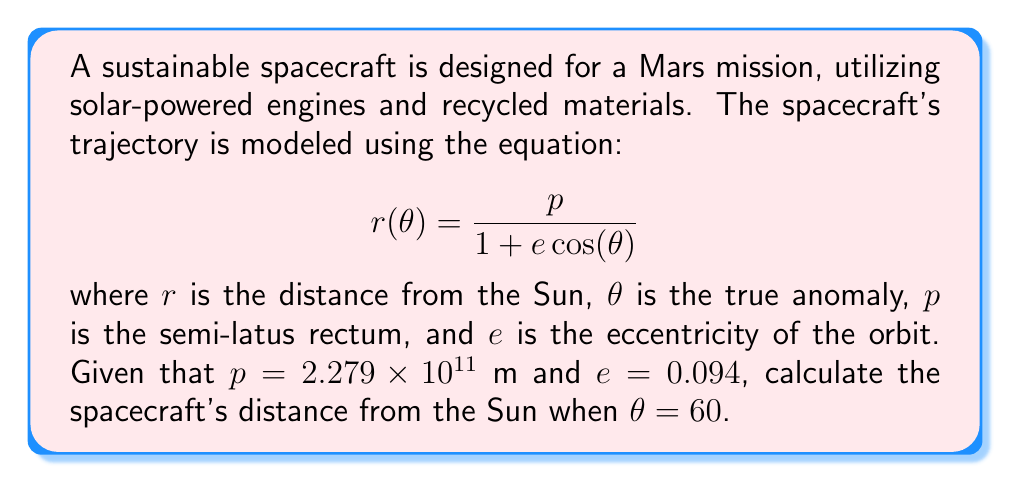Can you solve this math problem? To solve this problem, we'll follow these steps:

1. Identify the given values:
   $p = 2.279 \times 10^{11}$ m
   $e = 0.094$
   $\theta = 60°$

2. Convert 60° to radians:
   $60° = \frac{60 \pi}{180} = \frac{\pi}{3}$ radians

3. Substitute the values into the equation:
   $$r(\theta) = \frac{p}{1 + e \cos(\theta)}$$
   $$r(\frac{\pi}{3}) = \frac{2.279 \times 10^{11}}{1 + 0.094 \cos(\frac{\pi}{3})}$$

4. Calculate $\cos(\frac{\pi}{3})$:
   $\cos(\frac{\pi}{3}) = 0.5$

5. Substitute this value:
   $$r(\frac{\pi}{3}) = \frac{2.279 \times 10^{11}}{1 + 0.094 \cdot 0.5}$$

6. Simplify the denominator:
   $$r(\frac{\pi}{3}) = \frac{2.279 \times 10^{11}}{1 + 0.047}$$
   $$r(\frac{\pi}{3}) = \frac{2.279 \times 10^{11}}{1.047}$$

7. Perform the division:
   $$r(\frac{\pi}{3}) = 2.177 \times 10^{11}$$ m

Therefore, the spacecraft's distance from the Sun when $\theta = 60°$ is approximately $2.177 \times 10^{11}$ meters.
Answer: $2.177 \times 10^{11}$ m 